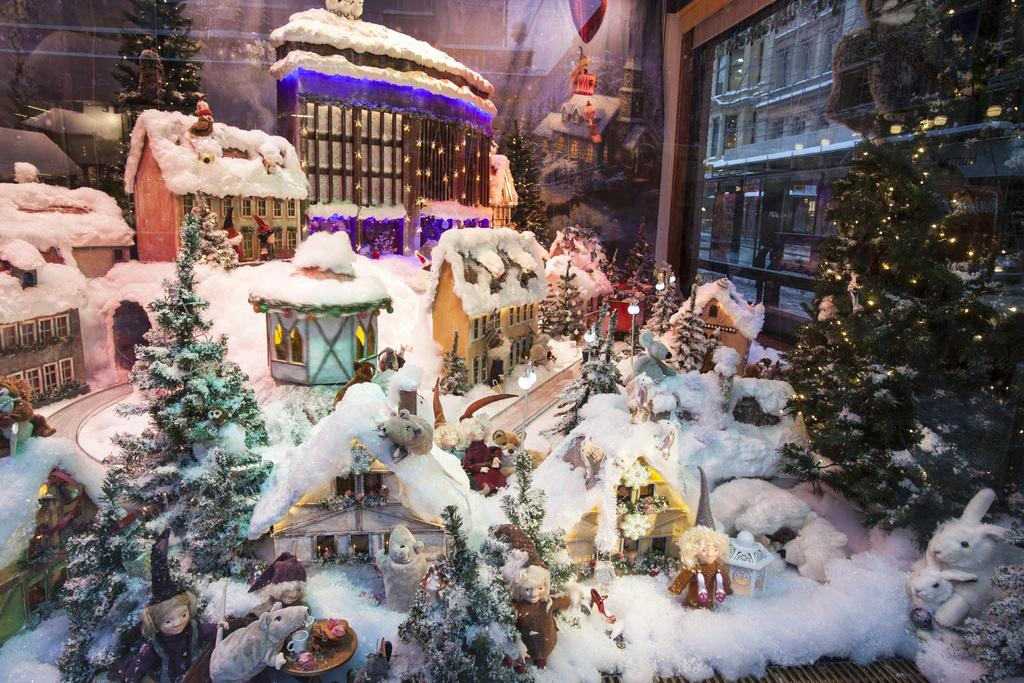What types of objects can be seen in the image? There are toys, decorative items, lights, a Christmas tree, glass objects, and a building visible in the image. Can you describe the Christmas tree in the image? The Christmas tree is decorated with lights and other decorative items. What material are the glass objects made of? The glass objects are made of glass, as indicated by the fact that they are transparent and reflect light. What is visible through the glass object? Objects visible through a glass object include the Christmas tree and other decorative items. How does the jam spread on the dirt in the image? There is no jam or dirt present in the image; it features toys, decorative items, lights, a Christmas tree, glass objects, and a building. 